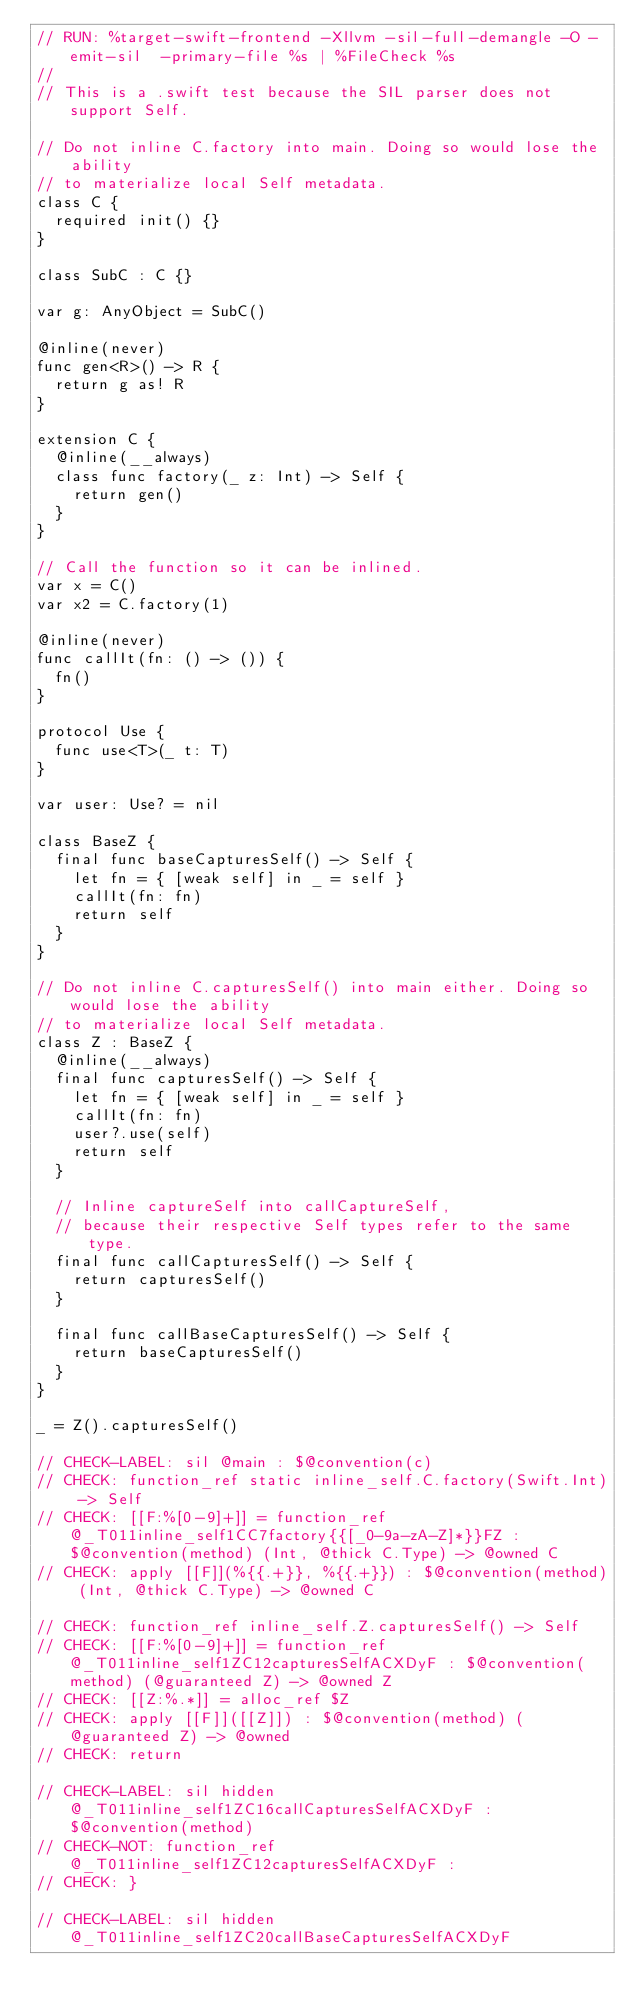Convert code to text. <code><loc_0><loc_0><loc_500><loc_500><_Swift_>// RUN: %target-swift-frontend -Xllvm -sil-full-demangle -O -emit-sil  -primary-file %s | %FileCheck %s
//
// This is a .swift test because the SIL parser does not support Self.

// Do not inline C.factory into main. Doing so would lose the ability
// to materialize local Self metadata.
class C {
  required init() {}
}

class SubC : C {}

var g: AnyObject = SubC()

@inline(never)
func gen<R>() -> R {
  return g as! R
}

extension C {
  @inline(__always)
  class func factory(_ z: Int) -> Self {
    return gen()
  }
}

// Call the function so it can be inlined.
var x = C()
var x2 = C.factory(1)

@inline(never)
func callIt(fn: () -> ()) {
  fn()
}

protocol Use {
  func use<T>(_ t: T)
}

var user: Use? = nil

class BaseZ {
  final func baseCapturesSelf() -> Self {
    let fn = { [weak self] in _ = self }
    callIt(fn: fn)
    return self
  }
}

// Do not inline C.capturesSelf() into main either. Doing so would lose the ability
// to materialize local Self metadata.
class Z : BaseZ {
  @inline(__always)
  final func capturesSelf() -> Self {
    let fn = { [weak self] in _ = self }
    callIt(fn: fn)
    user?.use(self)
    return self
  }

  // Inline captureSelf into callCaptureSelf,
  // because their respective Self types refer to the same type.
  final func callCapturesSelf() -> Self {
    return capturesSelf()
  }

  final func callBaseCapturesSelf() -> Self {
    return baseCapturesSelf()
  }
}

_ = Z().capturesSelf()

// CHECK-LABEL: sil @main : $@convention(c)
// CHECK: function_ref static inline_self.C.factory(Swift.Int) -> Self
// CHECK: [[F:%[0-9]+]] = function_ref @_T011inline_self1CC7factory{{[_0-9a-zA-Z]*}}FZ : $@convention(method) (Int, @thick C.Type) -> @owned C
// CHECK: apply [[F]](%{{.+}}, %{{.+}}) : $@convention(method) (Int, @thick C.Type) -> @owned C

// CHECK: function_ref inline_self.Z.capturesSelf() -> Self
// CHECK: [[F:%[0-9]+]] = function_ref @_T011inline_self1ZC12capturesSelfACXDyF : $@convention(method) (@guaranteed Z) -> @owned Z
// CHECK: [[Z:%.*]] = alloc_ref $Z
// CHECK: apply [[F]]([[Z]]) : $@convention(method) (@guaranteed Z) -> @owned
// CHECK: return

// CHECK-LABEL: sil hidden @_T011inline_self1ZC16callCapturesSelfACXDyF : $@convention(method)
// CHECK-NOT: function_ref @_T011inline_self1ZC12capturesSelfACXDyF :
// CHECK: }

// CHECK-LABEL: sil hidden @_T011inline_self1ZC20callBaseCapturesSelfACXDyF</code> 